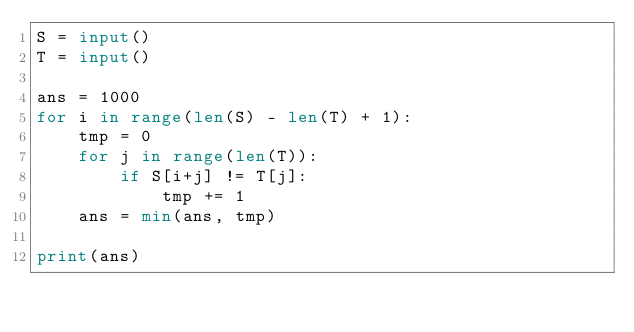Convert code to text. <code><loc_0><loc_0><loc_500><loc_500><_Python_>S = input()
T = input()

ans = 1000
for i in range(len(S) - len(T) + 1):
    tmp = 0
    for j in range(len(T)):
        if S[i+j] != T[j]:
            tmp += 1
    ans = min(ans, tmp)

print(ans)</code> 